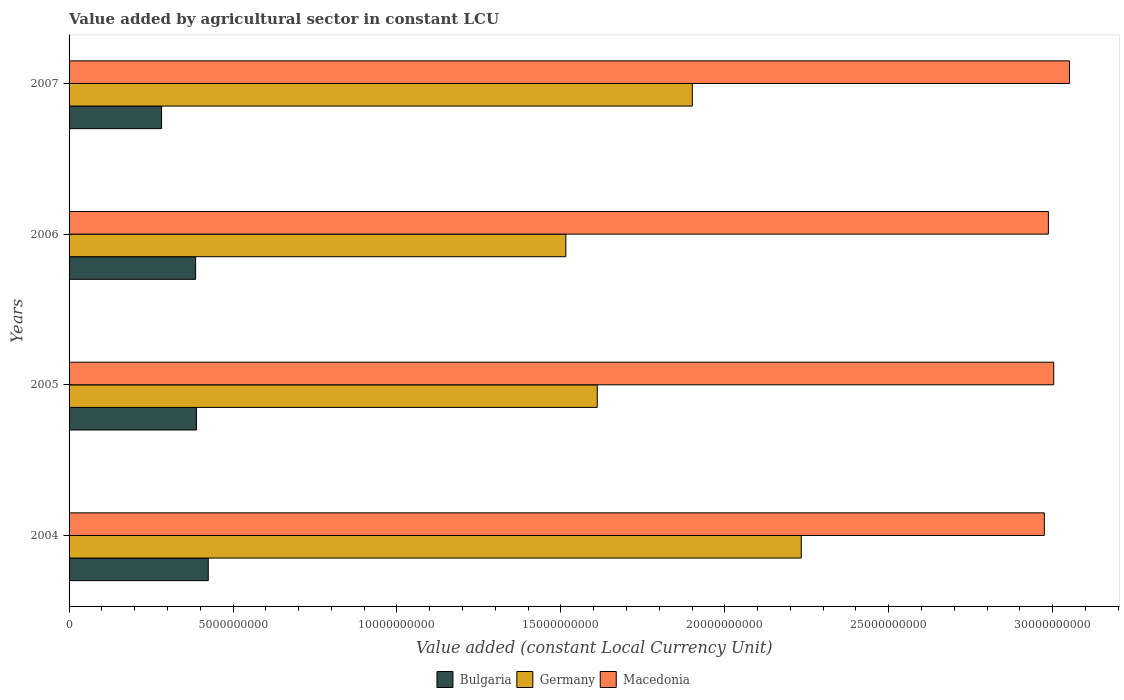Are the number of bars per tick equal to the number of legend labels?
Your answer should be compact. Yes. Are the number of bars on each tick of the Y-axis equal?
Your answer should be very brief. Yes. How many bars are there on the 1st tick from the top?
Your answer should be very brief. 3. How many bars are there on the 4th tick from the bottom?
Your answer should be very brief. 3. What is the value added by agricultural sector in Macedonia in 2007?
Make the answer very short. 3.05e+1. Across all years, what is the maximum value added by agricultural sector in Bulgaria?
Make the answer very short. 4.25e+09. Across all years, what is the minimum value added by agricultural sector in Macedonia?
Give a very brief answer. 2.97e+1. What is the total value added by agricultural sector in Germany in the graph?
Give a very brief answer. 7.26e+1. What is the difference between the value added by agricultural sector in Macedonia in 2005 and that in 2007?
Offer a terse response. -4.81e+08. What is the difference between the value added by agricultural sector in Germany in 2006 and the value added by agricultural sector in Bulgaria in 2005?
Your answer should be very brief. 1.13e+1. What is the average value added by agricultural sector in Macedonia per year?
Make the answer very short. 3.00e+1. In the year 2006, what is the difference between the value added by agricultural sector in Macedonia and value added by agricultural sector in Germany?
Make the answer very short. 1.47e+1. What is the ratio of the value added by agricultural sector in Germany in 2004 to that in 2005?
Ensure brevity in your answer.  1.39. What is the difference between the highest and the second highest value added by agricultural sector in Bulgaria?
Provide a succinct answer. 3.60e+08. What is the difference between the highest and the lowest value added by agricultural sector in Germany?
Provide a short and direct response. 7.18e+09. In how many years, is the value added by agricultural sector in Macedonia greater than the average value added by agricultural sector in Macedonia taken over all years?
Keep it short and to the point. 1. Is the sum of the value added by agricultural sector in Bulgaria in 2004 and 2005 greater than the maximum value added by agricultural sector in Macedonia across all years?
Your answer should be very brief. No. What does the 3rd bar from the bottom in 2005 represents?
Your answer should be very brief. Macedonia. How many bars are there?
Offer a very short reply. 12. Are all the bars in the graph horizontal?
Your answer should be very brief. Yes. What is the difference between two consecutive major ticks on the X-axis?
Ensure brevity in your answer.  5.00e+09. How many legend labels are there?
Offer a very short reply. 3. How are the legend labels stacked?
Provide a short and direct response. Horizontal. What is the title of the graph?
Your answer should be very brief. Value added by agricultural sector in constant LCU. Does "Benin" appear as one of the legend labels in the graph?
Offer a very short reply. No. What is the label or title of the X-axis?
Your answer should be very brief. Value added (constant Local Currency Unit). What is the Value added (constant Local Currency Unit) of Bulgaria in 2004?
Your answer should be compact. 4.25e+09. What is the Value added (constant Local Currency Unit) in Germany in 2004?
Your response must be concise. 2.23e+1. What is the Value added (constant Local Currency Unit) in Macedonia in 2004?
Offer a terse response. 2.97e+1. What is the Value added (constant Local Currency Unit) of Bulgaria in 2005?
Give a very brief answer. 3.89e+09. What is the Value added (constant Local Currency Unit) in Germany in 2005?
Your response must be concise. 1.61e+1. What is the Value added (constant Local Currency Unit) in Macedonia in 2005?
Ensure brevity in your answer.  3.00e+1. What is the Value added (constant Local Currency Unit) of Bulgaria in 2006?
Make the answer very short. 3.86e+09. What is the Value added (constant Local Currency Unit) of Germany in 2006?
Your response must be concise. 1.52e+1. What is the Value added (constant Local Currency Unit) in Macedonia in 2006?
Give a very brief answer. 2.99e+1. What is the Value added (constant Local Currency Unit) in Bulgaria in 2007?
Offer a very short reply. 2.82e+09. What is the Value added (constant Local Currency Unit) in Germany in 2007?
Offer a terse response. 1.90e+1. What is the Value added (constant Local Currency Unit) in Macedonia in 2007?
Your response must be concise. 3.05e+1. Across all years, what is the maximum Value added (constant Local Currency Unit) in Bulgaria?
Your answer should be compact. 4.25e+09. Across all years, what is the maximum Value added (constant Local Currency Unit) of Germany?
Your answer should be compact. 2.23e+1. Across all years, what is the maximum Value added (constant Local Currency Unit) of Macedonia?
Offer a very short reply. 3.05e+1. Across all years, what is the minimum Value added (constant Local Currency Unit) of Bulgaria?
Make the answer very short. 2.82e+09. Across all years, what is the minimum Value added (constant Local Currency Unit) of Germany?
Give a very brief answer. 1.52e+1. Across all years, what is the minimum Value added (constant Local Currency Unit) in Macedonia?
Provide a short and direct response. 2.97e+1. What is the total Value added (constant Local Currency Unit) in Bulgaria in the graph?
Provide a succinct answer. 1.48e+1. What is the total Value added (constant Local Currency Unit) in Germany in the graph?
Your answer should be very brief. 7.26e+1. What is the total Value added (constant Local Currency Unit) of Macedonia in the graph?
Your answer should be compact. 1.20e+11. What is the difference between the Value added (constant Local Currency Unit) of Bulgaria in 2004 and that in 2005?
Keep it short and to the point. 3.60e+08. What is the difference between the Value added (constant Local Currency Unit) in Germany in 2004 and that in 2005?
Your answer should be compact. 6.22e+09. What is the difference between the Value added (constant Local Currency Unit) in Macedonia in 2004 and that in 2005?
Offer a very short reply. -2.86e+08. What is the difference between the Value added (constant Local Currency Unit) of Bulgaria in 2004 and that in 2006?
Your answer should be compact. 3.86e+08. What is the difference between the Value added (constant Local Currency Unit) in Germany in 2004 and that in 2006?
Your response must be concise. 7.18e+09. What is the difference between the Value added (constant Local Currency Unit) of Macedonia in 2004 and that in 2006?
Your answer should be compact. -1.23e+08. What is the difference between the Value added (constant Local Currency Unit) in Bulgaria in 2004 and that in 2007?
Your answer should be very brief. 1.42e+09. What is the difference between the Value added (constant Local Currency Unit) in Germany in 2004 and that in 2007?
Offer a very short reply. 3.32e+09. What is the difference between the Value added (constant Local Currency Unit) of Macedonia in 2004 and that in 2007?
Your response must be concise. -7.67e+08. What is the difference between the Value added (constant Local Currency Unit) in Bulgaria in 2005 and that in 2006?
Offer a terse response. 2.54e+07. What is the difference between the Value added (constant Local Currency Unit) of Germany in 2005 and that in 2006?
Offer a very short reply. 9.57e+08. What is the difference between the Value added (constant Local Currency Unit) in Macedonia in 2005 and that in 2006?
Provide a succinct answer. 1.63e+08. What is the difference between the Value added (constant Local Currency Unit) of Bulgaria in 2005 and that in 2007?
Your answer should be very brief. 1.06e+09. What is the difference between the Value added (constant Local Currency Unit) of Germany in 2005 and that in 2007?
Provide a succinct answer. -2.90e+09. What is the difference between the Value added (constant Local Currency Unit) of Macedonia in 2005 and that in 2007?
Keep it short and to the point. -4.81e+08. What is the difference between the Value added (constant Local Currency Unit) of Bulgaria in 2006 and that in 2007?
Offer a very short reply. 1.04e+09. What is the difference between the Value added (constant Local Currency Unit) of Germany in 2006 and that in 2007?
Keep it short and to the point. -3.86e+09. What is the difference between the Value added (constant Local Currency Unit) of Macedonia in 2006 and that in 2007?
Offer a terse response. -6.44e+08. What is the difference between the Value added (constant Local Currency Unit) of Bulgaria in 2004 and the Value added (constant Local Currency Unit) of Germany in 2005?
Offer a very short reply. -1.19e+1. What is the difference between the Value added (constant Local Currency Unit) of Bulgaria in 2004 and the Value added (constant Local Currency Unit) of Macedonia in 2005?
Keep it short and to the point. -2.58e+1. What is the difference between the Value added (constant Local Currency Unit) of Germany in 2004 and the Value added (constant Local Currency Unit) of Macedonia in 2005?
Offer a terse response. -7.70e+09. What is the difference between the Value added (constant Local Currency Unit) in Bulgaria in 2004 and the Value added (constant Local Currency Unit) in Germany in 2006?
Offer a terse response. -1.09e+1. What is the difference between the Value added (constant Local Currency Unit) of Bulgaria in 2004 and the Value added (constant Local Currency Unit) of Macedonia in 2006?
Offer a very short reply. -2.56e+1. What is the difference between the Value added (constant Local Currency Unit) of Germany in 2004 and the Value added (constant Local Currency Unit) of Macedonia in 2006?
Ensure brevity in your answer.  -7.54e+09. What is the difference between the Value added (constant Local Currency Unit) in Bulgaria in 2004 and the Value added (constant Local Currency Unit) in Germany in 2007?
Offer a terse response. -1.48e+1. What is the difference between the Value added (constant Local Currency Unit) of Bulgaria in 2004 and the Value added (constant Local Currency Unit) of Macedonia in 2007?
Offer a very short reply. -2.63e+1. What is the difference between the Value added (constant Local Currency Unit) in Germany in 2004 and the Value added (constant Local Currency Unit) in Macedonia in 2007?
Provide a short and direct response. -8.18e+09. What is the difference between the Value added (constant Local Currency Unit) of Bulgaria in 2005 and the Value added (constant Local Currency Unit) of Germany in 2006?
Your answer should be very brief. -1.13e+1. What is the difference between the Value added (constant Local Currency Unit) of Bulgaria in 2005 and the Value added (constant Local Currency Unit) of Macedonia in 2006?
Keep it short and to the point. -2.60e+1. What is the difference between the Value added (constant Local Currency Unit) of Germany in 2005 and the Value added (constant Local Currency Unit) of Macedonia in 2006?
Make the answer very short. -1.38e+1. What is the difference between the Value added (constant Local Currency Unit) in Bulgaria in 2005 and the Value added (constant Local Currency Unit) in Germany in 2007?
Provide a succinct answer. -1.51e+1. What is the difference between the Value added (constant Local Currency Unit) of Bulgaria in 2005 and the Value added (constant Local Currency Unit) of Macedonia in 2007?
Give a very brief answer. -2.66e+1. What is the difference between the Value added (constant Local Currency Unit) in Germany in 2005 and the Value added (constant Local Currency Unit) in Macedonia in 2007?
Your response must be concise. -1.44e+1. What is the difference between the Value added (constant Local Currency Unit) in Bulgaria in 2006 and the Value added (constant Local Currency Unit) in Germany in 2007?
Provide a succinct answer. -1.51e+1. What is the difference between the Value added (constant Local Currency Unit) of Bulgaria in 2006 and the Value added (constant Local Currency Unit) of Macedonia in 2007?
Offer a terse response. -2.67e+1. What is the difference between the Value added (constant Local Currency Unit) of Germany in 2006 and the Value added (constant Local Currency Unit) of Macedonia in 2007?
Offer a very short reply. -1.54e+1. What is the average Value added (constant Local Currency Unit) in Bulgaria per year?
Offer a terse response. 3.70e+09. What is the average Value added (constant Local Currency Unit) in Germany per year?
Provide a short and direct response. 1.82e+1. What is the average Value added (constant Local Currency Unit) of Macedonia per year?
Provide a succinct answer. 3.00e+1. In the year 2004, what is the difference between the Value added (constant Local Currency Unit) of Bulgaria and Value added (constant Local Currency Unit) of Germany?
Your response must be concise. -1.81e+1. In the year 2004, what is the difference between the Value added (constant Local Currency Unit) of Bulgaria and Value added (constant Local Currency Unit) of Macedonia?
Ensure brevity in your answer.  -2.55e+1. In the year 2004, what is the difference between the Value added (constant Local Currency Unit) in Germany and Value added (constant Local Currency Unit) in Macedonia?
Offer a very short reply. -7.41e+09. In the year 2005, what is the difference between the Value added (constant Local Currency Unit) of Bulgaria and Value added (constant Local Currency Unit) of Germany?
Your answer should be very brief. -1.22e+1. In the year 2005, what is the difference between the Value added (constant Local Currency Unit) of Bulgaria and Value added (constant Local Currency Unit) of Macedonia?
Offer a terse response. -2.61e+1. In the year 2005, what is the difference between the Value added (constant Local Currency Unit) in Germany and Value added (constant Local Currency Unit) in Macedonia?
Ensure brevity in your answer.  -1.39e+1. In the year 2006, what is the difference between the Value added (constant Local Currency Unit) of Bulgaria and Value added (constant Local Currency Unit) of Germany?
Offer a terse response. -1.13e+1. In the year 2006, what is the difference between the Value added (constant Local Currency Unit) in Bulgaria and Value added (constant Local Currency Unit) in Macedonia?
Your answer should be compact. -2.60e+1. In the year 2006, what is the difference between the Value added (constant Local Currency Unit) in Germany and Value added (constant Local Currency Unit) in Macedonia?
Provide a short and direct response. -1.47e+1. In the year 2007, what is the difference between the Value added (constant Local Currency Unit) in Bulgaria and Value added (constant Local Currency Unit) in Germany?
Provide a short and direct response. -1.62e+1. In the year 2007, what is the difference between the Value added (constant Local Currency Unit) in Bulgaria and Value added (constant Local Currency Unit) in Macedonia?
Offer a terse response. -2.77e+1. In the year 2007, what is the difference between the Value added (constant Local Currency Unit) of Germany and Value added (constant Local Currency Unit) of Macedonia?
Make the answer very short. -1.15e+1. What is the ratio of the Value added (constant Local Currency Unit) of Bulgaria in 2004 to that in 2005?
Make the answer very short. 1.09. What is the ratio of the Value added (constant Local Currency Unit) in Germany in 2004 to that in 2005?
Your answer should be compact. 1.39. What is the ratio of the Value added (constant Local Currency Unit) of Macedonia in 2004 to that in 2005?
Keep it short and to the point. 0.99. What is the ratio of the Value added (constant Local Currency Unit) in Bulgaria in 2004 to that in 2006?
Your response must be concise. 1.1. What is the ratio of the Value added (constant Local Currency Unit) in Germany in 2004 to that in 2006?
Make the answer very short. 1.47. What is the ratio of the Value added (constant Local Currency Unit) of Bulgaria in 2004 to that in 2007?
Your response must be concise. 1.5. What is the ratio of the Value added (constant Local Currency Unit) in Germany in 2004 to that in 2007?
Keep it short and to the point. 1.17. What is the ratio of the Value added (constant Local Currency Unit) of Macedonia in 2004 to that in 2007?
Keep it short and to the point. 0.97. What is the ratio of the Value added (constant Local Currency Unit) in Bulgaria in 2005 to that in 2006?
Ensure brevity in your answer.  1.01. What is the ratio of the Value added (constant Local Currency Unit) of Germany in 2005 to that in 2006?
Offer a terse response. 1.06. What is the ratio of the Value added (constant Local Currency Unit) in Macedonia in 2005 to that in 2006?
Ensure brevity in your answer.  1.01. What is the ratio of the Value added (constant Local Currency Unit) in Bulgaria in 2005 to that in 2007?
Ensure brevity in your answer.  1.38. What is the ratio of the Value added (constant Local Currency Unit) of Germany in 2005 to that in 2007?
Give a very brief answer. 0.85. What is the ratio of the Value added (constant Local Currency Unit) of Macedonia in 2005 to that in 2007?
Give a very brief answer. 0.98. What is the ratio of the Value added (constant Local Currency Unit) in Bulgaria in 2006 to that in 2007?
Your answer should be very brief. 1.37. What is the ratio of the Value added (constant Local Currency Unit) in Germany in 2006 to that in 2007?
Give a very brief answer. 0.8. What is the ratio of the Value added (constant Local Currency Unit) of Macedonia in 2006 to that in 2007?
Your response must be concise. 0.98. What is the difference between the highest and the second highest Value added (constant Local Currency Unit) of Bulgaria?
Provide a succinct answer. 3.60e+08. What is the difference between the highest and the second highest Value added (constant Local Currency Unit) in Germany?
Make the answer very short. 3.32e+09. What is the difference between the highest and the second highest Value added (constant Local Currency Unit) of Macedonia?
Make the answer very short. 4.81e+08. What is the difference between the highest and the lowest Value added (constant Local Currency Unit) in Bulgaria?
Your response must be concise. 1.42e+09. What is the difference between the highest and the lowest Value added (constant Local Currency Unit) in Germany?
Provide a succinct answer. 7.18e+09. What is the difference between the highest and the lowest Value added (constant Local Currency Unit) in Macedonia?
Provide a succinct answer. 7.67e+08. 